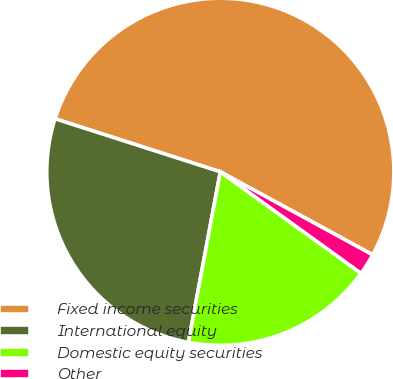Convert chart. <chart><loc_0><loc_0><loc_500><loc_500><pie_chart><fcel>Fixed income securities<fcel>International equity<fcel>Domestic equity securities<fcel>Other<nl><fcel>53.0%<fcel>27.0%<fcel>18.0%<fcel>2.0%<nl></chart> 